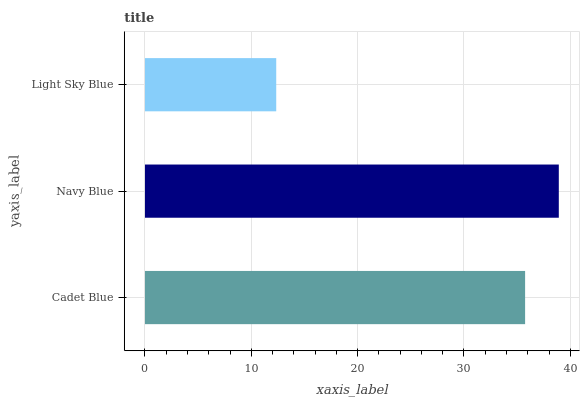Is Light Sky Blue the minimum?
Answer yes or no. Yes. Is Navy Blue the maximum?
Answer yes or no. Yes. Is Navy Blue the minimum?
Answer yes or no. No. Is Light Sky Blue the maximum?
Answer yes or no. No. Is Navy Blue greater than Light Sky Blue?
Answer yes or no. Yes. Is Light Sky Blue less than Navy Blue?
Answer yes or no. Yes. Is Light Sky Blue greater than Navy Blue?
Answer yes or no. No. Is Navy Blue less than Light Sky Blue?
Answer yes or no. No. Is Cadet Blue the high median?
Answer yes or no. Yes. Is Cadet Blue the low median?
Answer yes or no. Yes. Is Light Sky Blue the high median?
Answer yes or no. No. Is Light Sky Blue the low median?
Answer yes or no. No. 